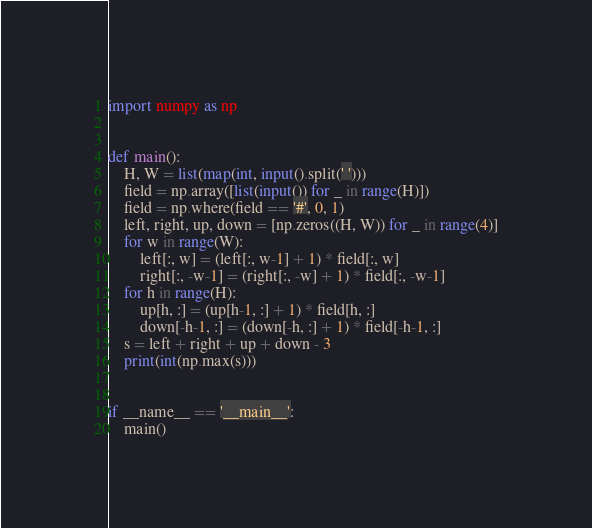Convert code to text. <code><loc_0><loc_0><loc_500><loc_500><_Python_>import numpy as np


def main():
    H, W = list(map(int, input().split(' ')))
    field = np.array([list(input()) for _ in range(H)])
    field = np.where(field == '#', 0, 1)
    left, right, up, down = [np.zeros((H, W)) for _ in range(4)]
    for w in range(W):
        left[:, w] = (left[:, w-1] + 1) * field[:, w]
        right[:, -w-1] = (right[:, -w] + 1) * field[:, -w-1]
    for h in range(H):
        up[h, :] = (up[h-1, :] + 1) * field[h, :]
        down[-h-1, :] = (down[-h, :] + 1) * field[-h-1, :]
    s = left + right + up + down - 3
    print(int(np.max(s)))


if __name__ == '__main__':
    main()</code> 